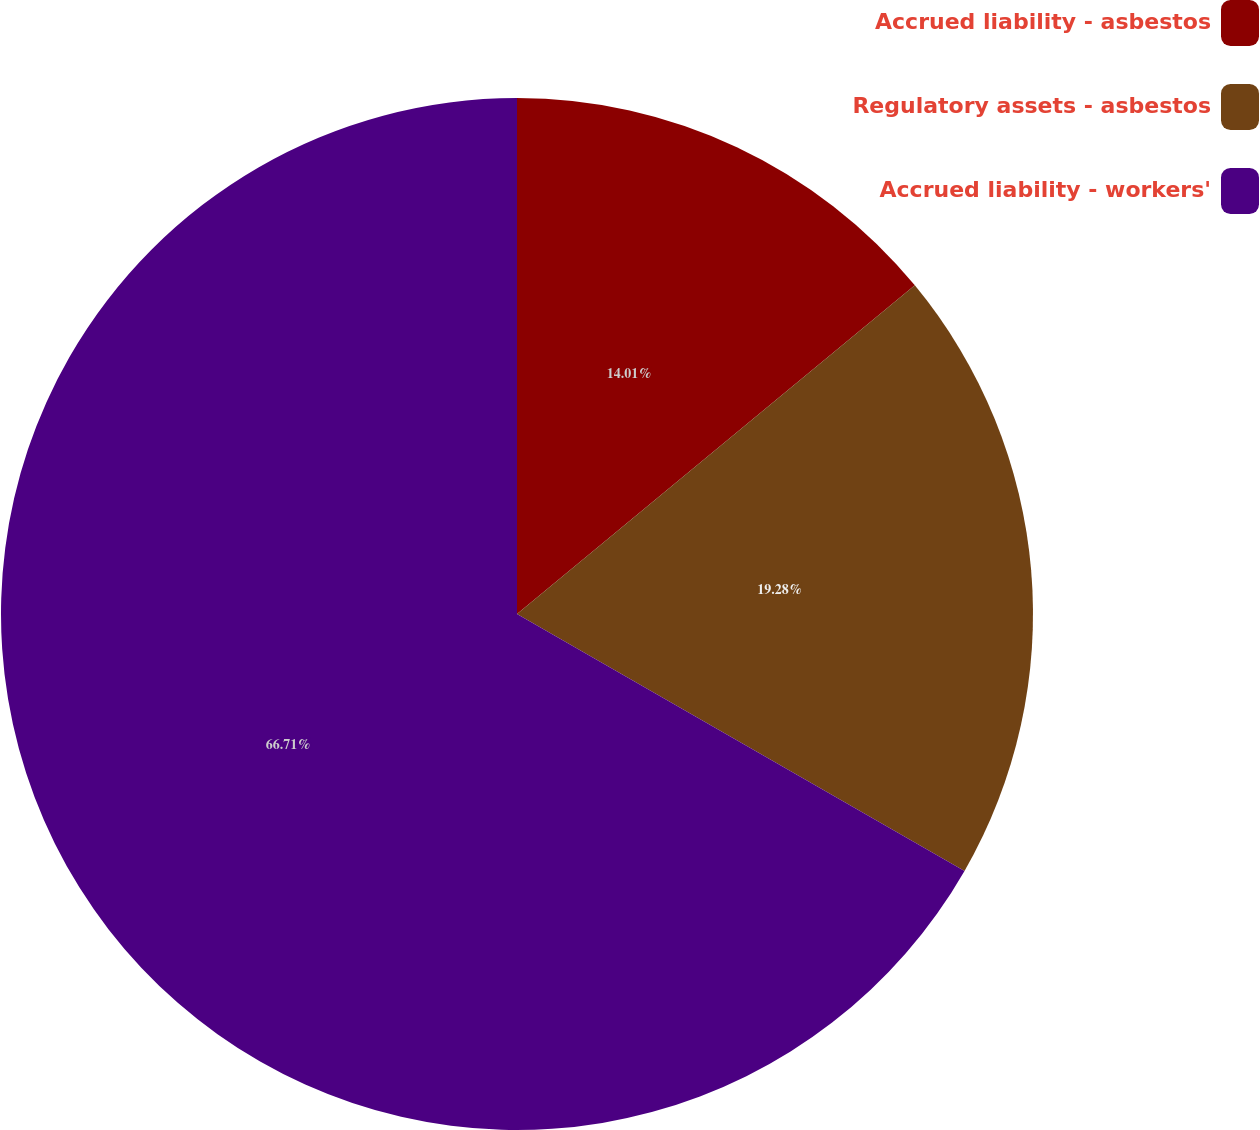<chart> <loc_0><loc_0><loc_500><loc_500><pie_chart><fcel>Accrued liability - asbestos<fcel>Regulatory assets - asbestos<fcel>Accrued liability - workers'<nl><fcel>14.01%<fcel>19.28%<fcel>66.7%<nl></chart> 